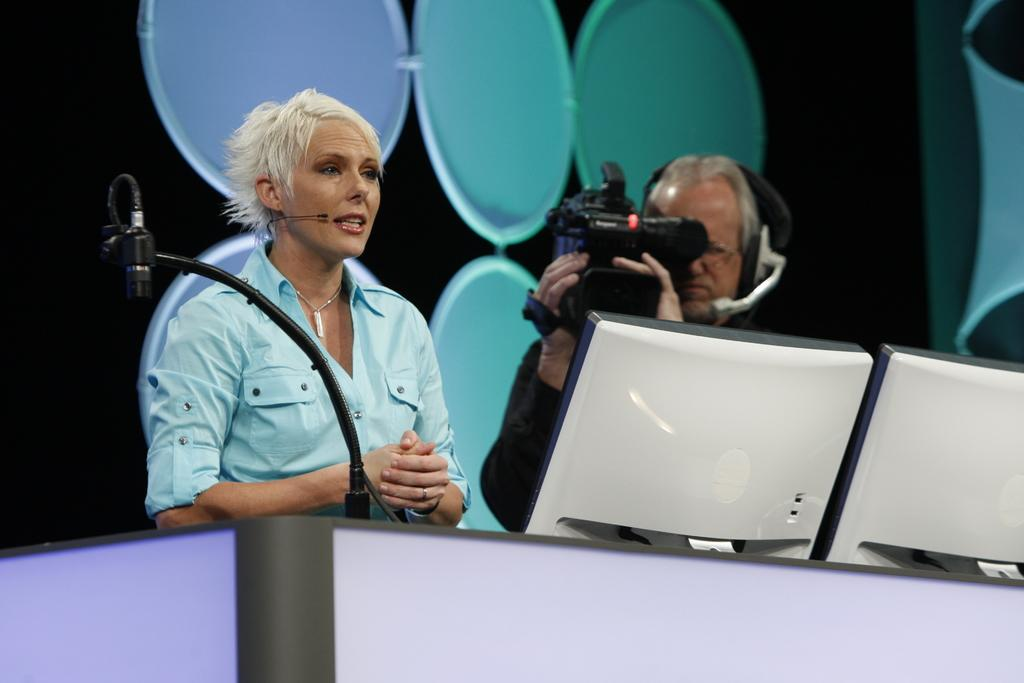What is the woman near in the image? The woman is standing near a podium in the image. What is on the podium in the image? There is a microphone on a stand on the podium in the image. Who else is present in the image? There is a man standing in the image. What is the man holding in his hand? The man is holding a video camera in his hand. What type of stamp can be seen on the woman's forehead in the image? There is no stamp visible on the woman's forehead in the image. What type of maid is present in the image? There is no maid present in the image. 